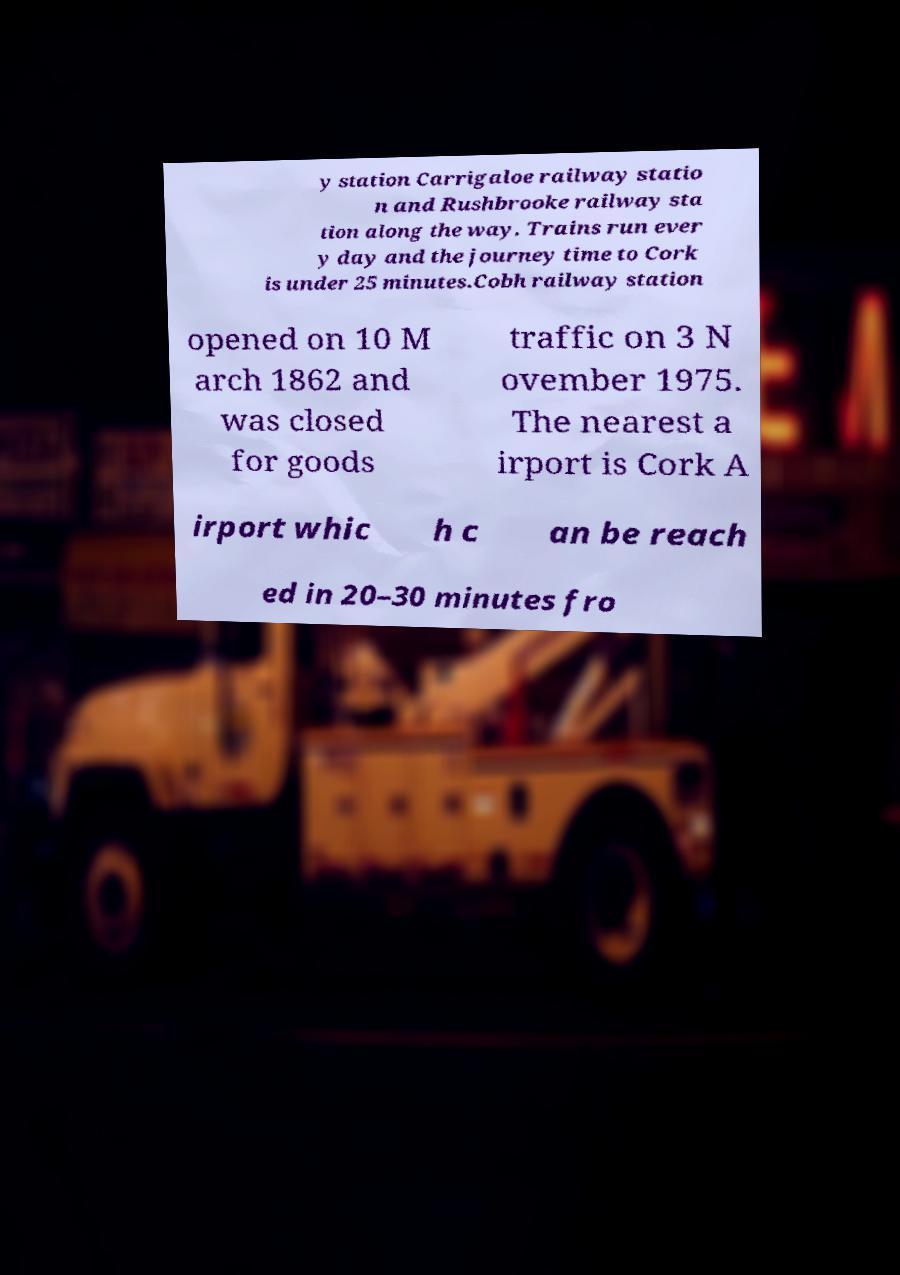Please read and relay the text visible in this image. What does it say? y station Carrigaloe railway statio n and Rushbrooke railway sta tion along the way. Trains run ever y day and the journey time to Cork is under 25 minutes.Cobh railway station opened on 10 M arch 1862 and was closed for goods traffic on 3 N ovember 1975. The nearest a irport is Cork A irport whic h c an be reach ed in 20–30 minutes fro 